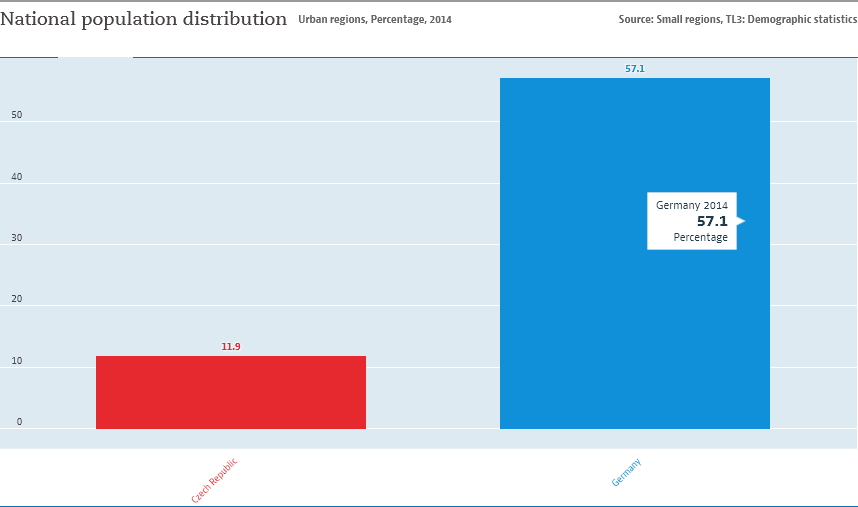Point out several critical features in this image. The ratio between the red and blue bars is 0.208406... The blue bar represents Germany. 